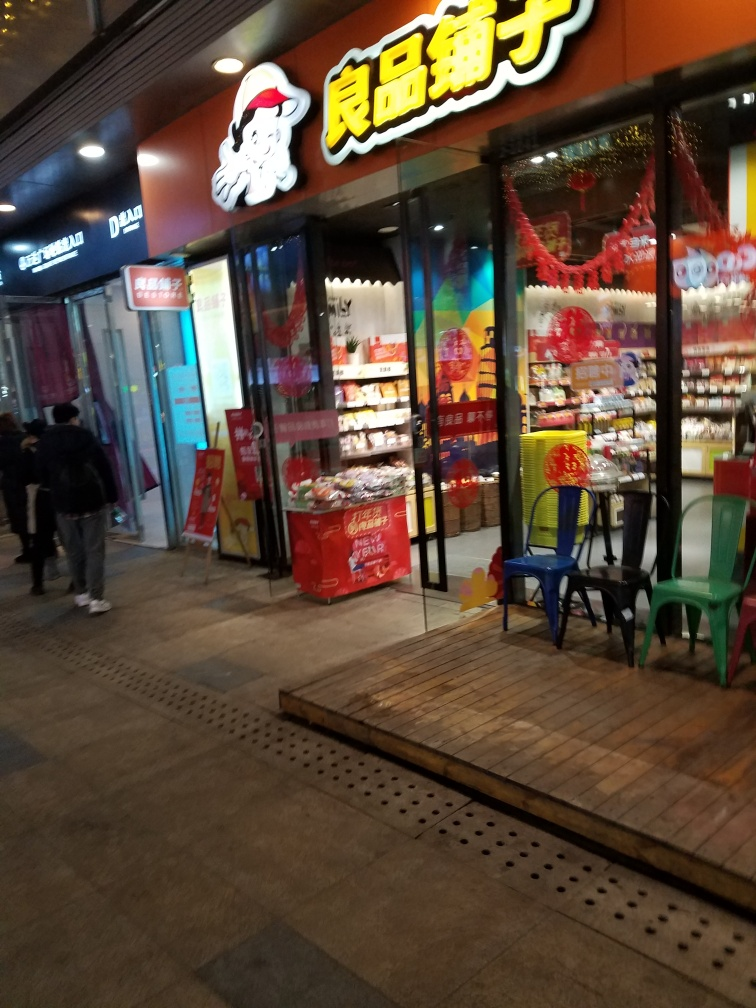Can you describe the style or atmosphere that this picture portrays? The picture captures an urban scene at night, showcasing a storefront with vibrant signage and colorful decorations. The atmosphere feels busy yet welcoming, with a storefront that seems to be a snack or specialty food shop, indicated by the various products displayed in the window. The lighting adds warmth to the scene, while the pedestrian partially in view and the arrangement of chairs outside suggest a casual, everyday setting. 